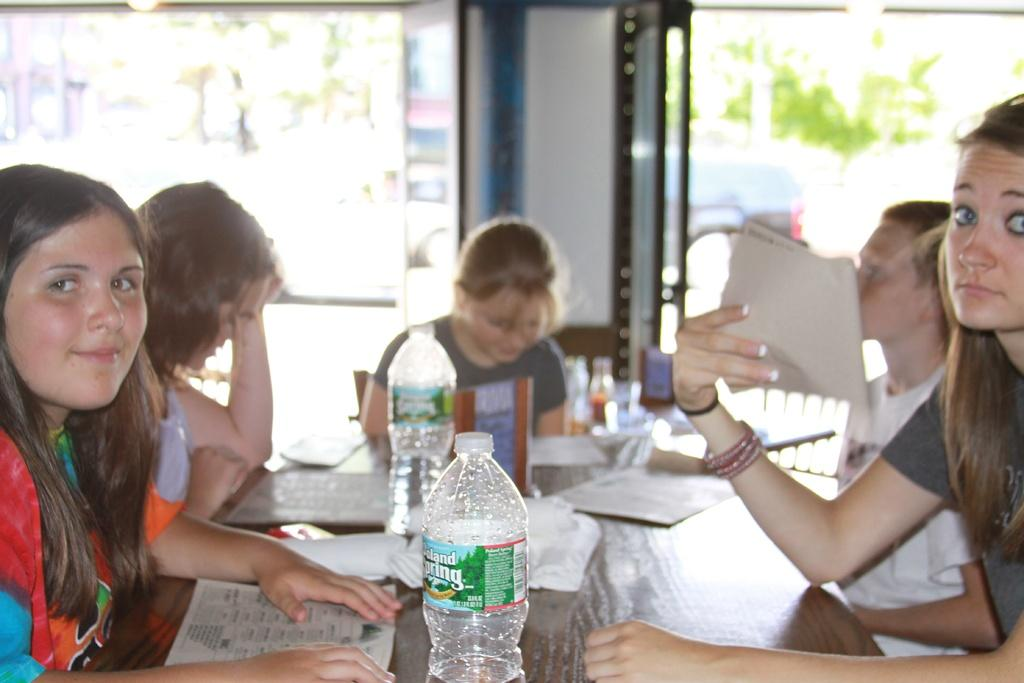How many people are in the image? There is a group of people in the image. What are the people doing in the image? The people are seated on chairs. What objects can be seen on the table in the image? There are papers, books, and water bottles on the table. Can you describe the woman in the image? There is a woman in the image, and she is holding a paper in her hand. What type of pest can be seen on the farm in the image? There is no farm or pest present in the image; it features a group of people seated around a table with various objects. 